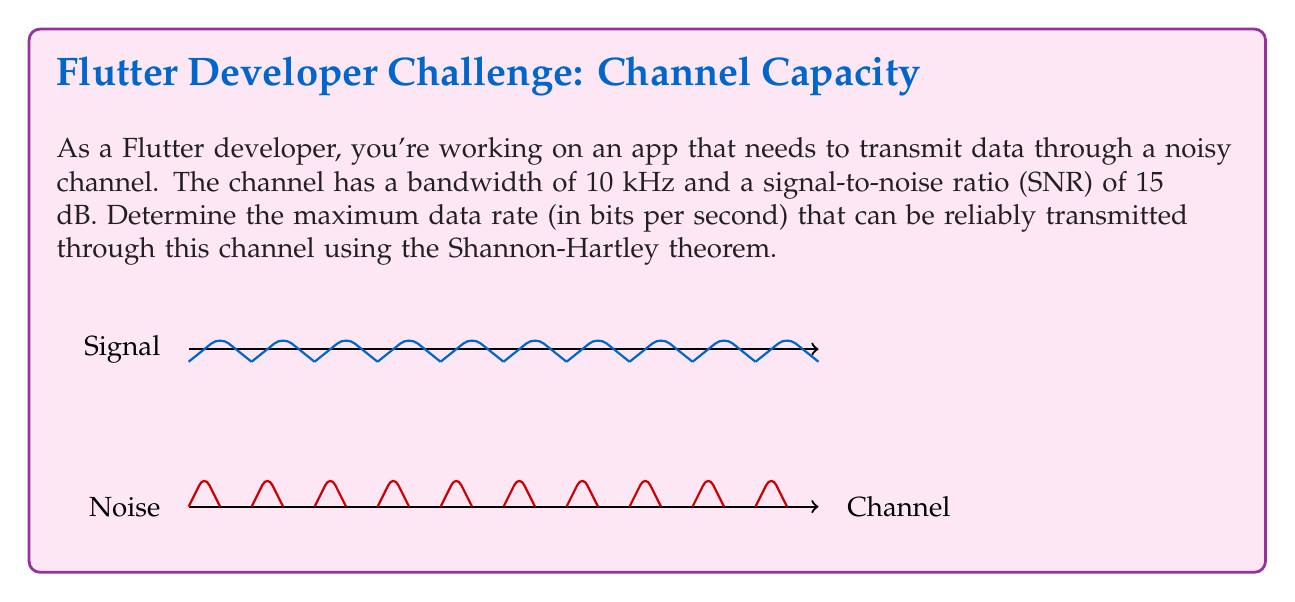Can you solve this math problem? To solve this problem, we'll use the Shannon-Hartley theorem, which gives the channel capacity C in bits per second:

$$C = B \log_2(1 + SNR)$$

Where:
- C is the channel capacity in bits per second
- B is the bandwidth in Hz
- SNR is the signal-to-noise ratio (linear, not dB)

Step 1: Convert the given bandwidth to Hz
B = 10 kHz = 10,000 Hz

Step 2: Convert SNR from dB to linear scale
SNR (dB) = 15 dB
SNR (linear) = $10^{(SNR_{dB} / 10)} = 10^{(15 / 10)} = 10^{1.5} \approx 31.6228$

Step 3: Apply the Shannon-Hartley theorem
$$\begin{align}
C &= B \log_2(1 + SNR) \\
&= 10,000 \cdot \log_2(1 + 31.6228) \\
&= 10,000 \cdot \log_2(32.6228) \\
&= 10,000 \cdot 5.0279 \\
&= 50,279 \text{ bits per second}
\end{align}$$

Therefore, the maximum data rate that can be reliably transmitted through this channel is approximately 50,279 bits per second.
Answer: 50,279 bits/s 